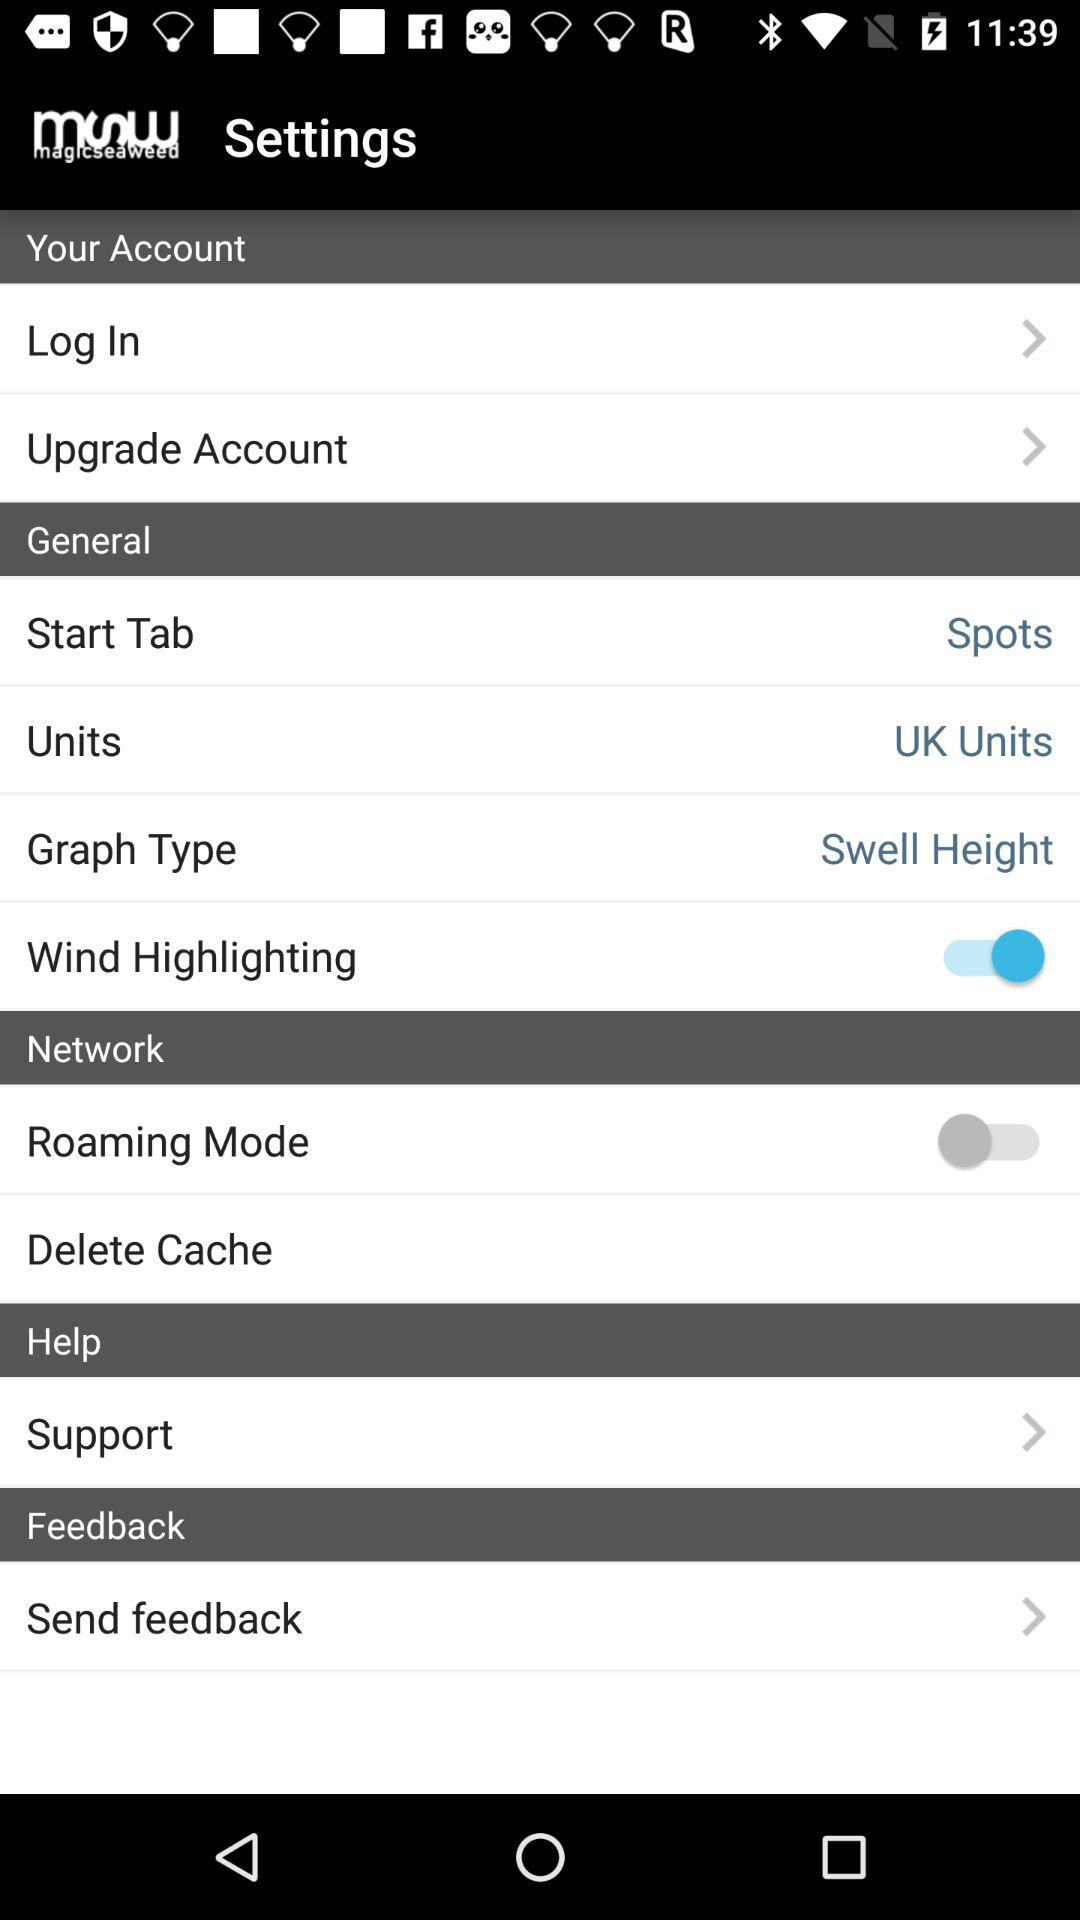What is the status of the "Wind Highlighting"? The status is "on". 